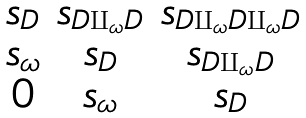Convert formula to latex. <formula><loc_0><loc_0><loc_500><loc_500>\begin{matrix} s _ { D } & s _ { D \amalg _ { \omega } D } & s _ { D \amalg _ { \omega } D \amalg _ { \omega } D } \\ s _ { \omega } & s _ { D } & s _ { D \amalg _ { \omega } D } \\ 0 & s _ { \omega } & s _ { D } \end{matrix}</formula> 